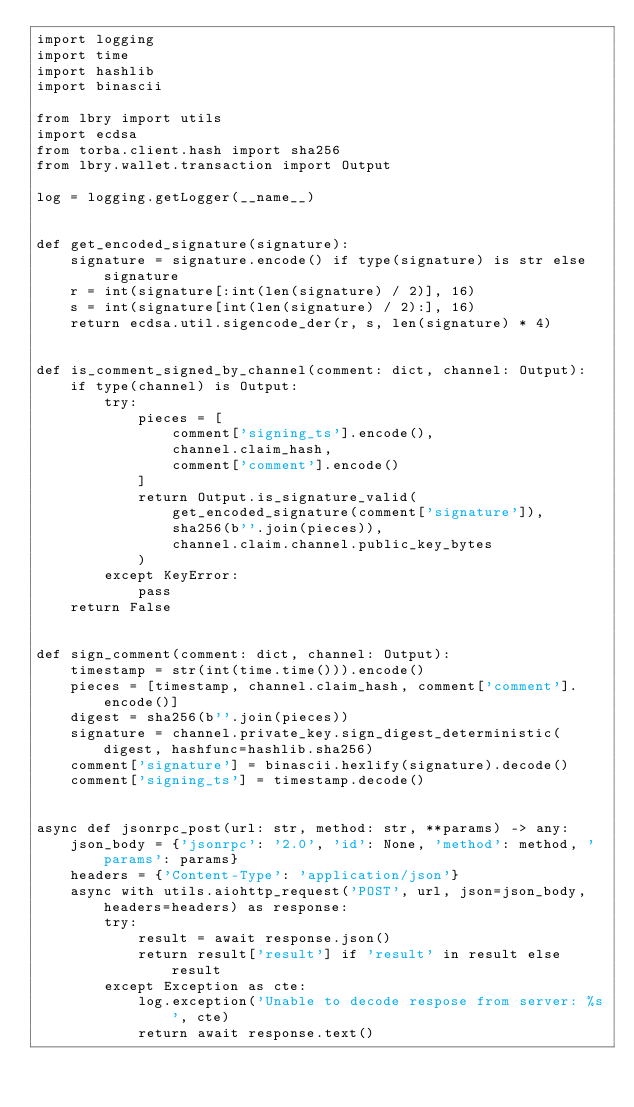Convert code to text. <code><loc_0><loc_0><loc_500><loc_500><_Python_>import logging
import time
import hashlib
import binascii

from lbry import utils
import ecdsa
from torba.client.hash import sha256
from lbry.wallet.transaction import Output

log = logging.getLogger(__name__)


def get_encoded_signature(signature):
    signature = signature.encode() if type(signature) is str else signature
    r = int(signature[:int(len(signature) / 2)], 16)
    s = int(signature[int(len(signature) / 2):], 16)
    return ecdsa.util.sigencode_der(r, s, len(signature) * 4)


def is_comment_signed_by_channel(comment: dict, channel: Output):
    if type(channel) is Output:
        try:
            pieces = [
                comment['signing_ts'].encode(),
                channel.claim_hash,
                comment['comment'].encode()
            ]
            return Output.is_signature_valid(
                get_encoded_signature(comment['signature']),
                sha256(b''.join(pieces)),
                channel.claim.channel.public_key_bytes
            )
        except KeyError:
            pass
    return False


def sign_comment(comment: dict, channel: Output):
    timestamp = str(int(time.time())).encode()
    pieces = [timestamp, channel.claim_hash, comment['comment'].encode()]
    digest = sha256(b''.join(pieces))
    signature = channel.private_key.sign_digest_deterministic(digest, hashfunc=hashlib.sha256)
    comment['signature'] = binascii.hexlify(signature).decode()
    comment['signing_ts'] = timestamp.decode()


async def jsonrpc_post(url: str, method: str, **params) -> any:
    json_body = {'jsonrpc': '2.0', 'id': None, 'method': method, 'params': params}
    headers = {'Content-Type': 'application/json'}
    async with utils.aiohttp_request('POST', url, json=json_body, headers=headers) as response:
        try:
            result = await response.json()
            return result['result'] if 'result' in result else result
        except Exception as cte:
            log.exception('Unable to decode respose from server: %s', cte)
            return await response.text()
</code> 